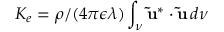<formula> <loc_0><loc_0><loc_500><loc_500>K _ { e } = \rho / ( 4 \pi \epsilon \lambda ) \int _ { \nu } \tilde { u } ^ { * } \cdot \tilde { u } \, d \nu</formula> 